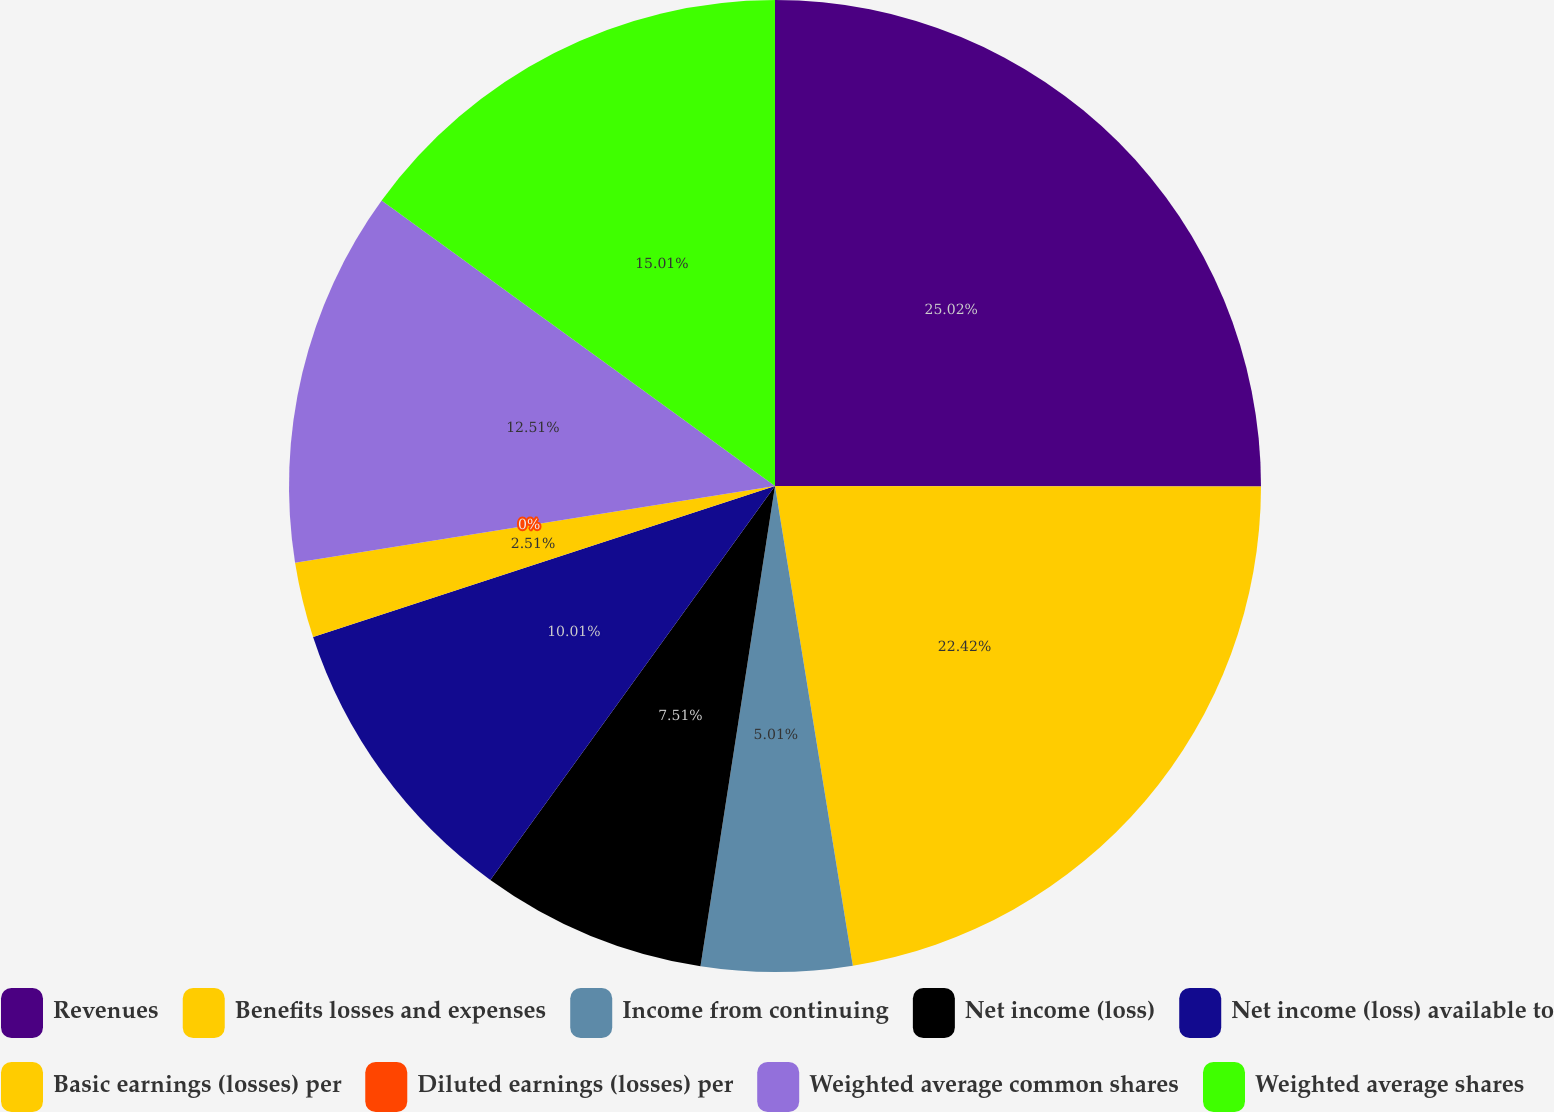<chart> <loc_0><loc_0><loc_500><loc_500><pie_chart><fcel>Revenues<fcel>Benefits losses and expenses<fcel>Income from continuing<fcel>Net income (loss)<fcel>Net income (loss) available to<fcel>Basic earnings (losses) per<fcel>Diluted earnings (losses) per<fcel>Weighted average common shares<fcel>Weighted average shares<nl><fcel>25.02%<fcel>22.42%<fcel>5.01%<fcel>7.51%<fcel>10.01%<fcel>2.51%<fcel>0.0%<fcel>12.51%<fcel>15.01%<nl></chart> 